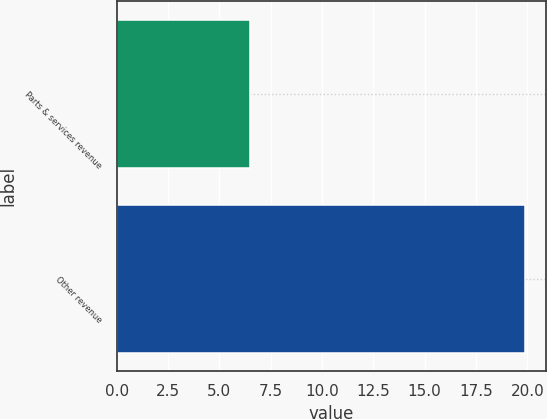<chart> <loc_0><loc_0><loc_500><loc_500><bar_chart><fcel>Parts & services revenue<fcel>Other revenue<nl><fcel>6.5<fcel>19.9<nl></chart> 